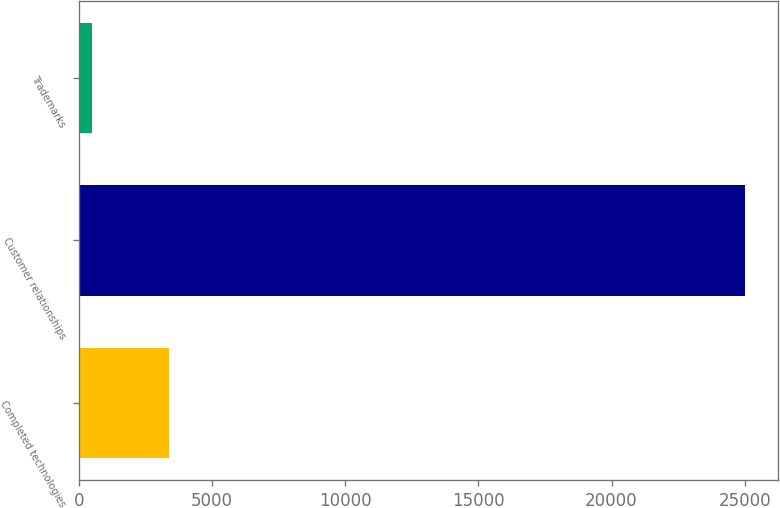Convert chart. <chart><loc_0><loc_0><loc_500><loc_500><bar_chart><fcel>Completed technologies<fcel>Customer relationships<fcel>Trademarks<nl><fcel>3400<fcel>25000<fcel>500<nl></chart> 